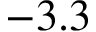Convert formula to latex. <formula><loc_0><loc_0><loc_500><loc_500>- 3 . 3</formula> 